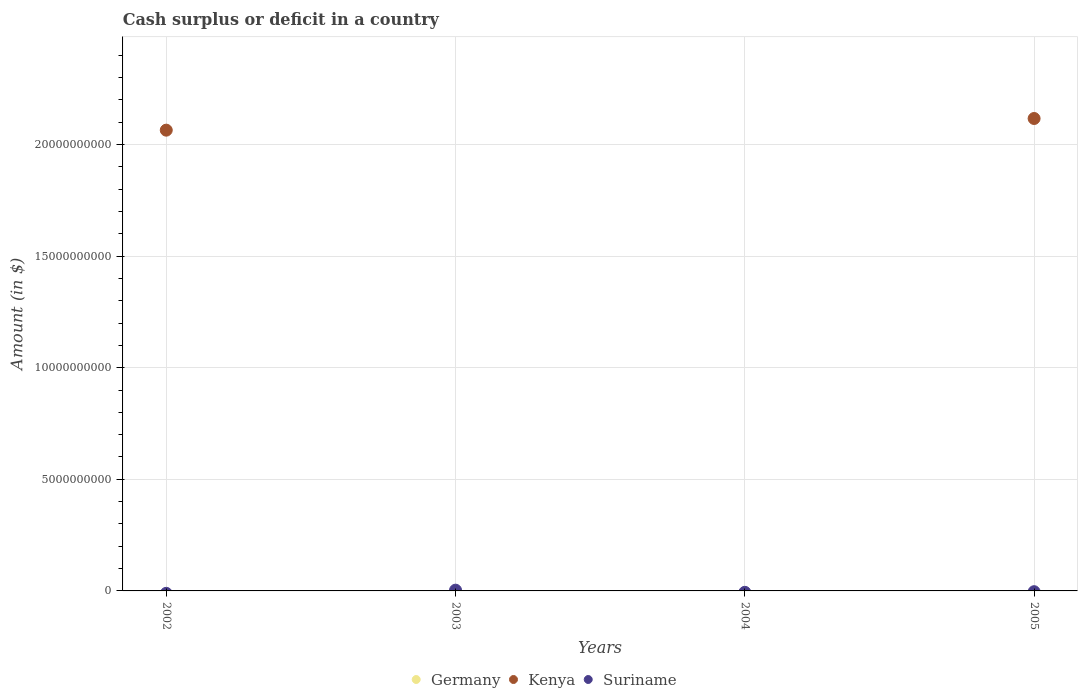What is the amount of cash surplus or deficit in Suriname in 2003?
Make the answer very short. 3.37e+07. Across all years, what is the maximum amount of cash surplus or deficit in Suriname?
Offer a very short reply. 3.37e+07. Across all years, what is the minimum amount of cash surplus or deficit in Kenya?
Provide a succinct answer. 0. What is the total amount of cash surplus or deficit in Suriname in the graph?
Offer a terse response. 3.37e+07. What is the difference between the amount of cash surplus or deficit in Kenya in 2002 and that in 2005?
Your answer should be compact. -5.22e+08. What is the difference between the amount of cash surplus or deficit in Germany in 2004 and the amount of cash surplus or deficit in Suriname in 2005?
Your response must be concise. 0. What is the average amount of cash surplus or deficit in Suriname per year?
Your answer should be compact. 8.43e+06. What is the difference between the highest and the lowest amount of cash surplus or deficit in Kenya?
Your answer should be compact. 2.12e+1. Does the amount of cash surplus or deficit in Germany monotonically increase over the years?
Provide a short and direct response. No. Is the amount of cash surplus or deficit in Kenya strictly greater than the amount of cash surplus or deficit in Germany over the years?
Offer a terse response. Yes. How many dotlines are there?
Provide a succinct answer. 2. What is the difference between two consecutive major ticks on the Y-axis?
Offer a terse response. 5.00e+09. Does the graph contain grids?
Your answer should be very brief. Yes. Where does the legend appear in the graph?
Provide a short and direct response. Bottom center. What is the title of the graph?
Provide a succinct answer. Cash surplus or deficit in a country. Does "Europe(developing only)" appear as one of the legend labels in the graph?
Your response must be concise. No. What is the label or title of the Y-axis?
Give a very brief answer. Amount (in $). What is the Amount (in $) in Germany in 2002?
Provide a succinct answer. 0. What is the Amount (in $) of Kenya in 2002?
Offer a terse response. 2.06e+1. What is the Amount (in $) of Kenya in 2003?
Ensure brevity in your answer.  0. What is the Amount (in $) of Suriname in 2003?
Provide a short and direct response. 3.37e+07. What is the Amount (in $) in Suriname in 2004?
Offer a terse response. 0. What is the Amount (in $) of Kenya in 2005?
Offer a very short reply. 2.12e+1. Across all years, what is the maximum Amount (in $) in Kenya?
Offer a terse response. 2.12e+1. Across all years, what is the maximum Amount (in $) in Suriname?
Offer a terse response. 3.37e+07. Across all years, what is the minimum Amount (in $) of Kenya?
Make the answer very short. 0. What is the total Amount (in $) in Germany in the graph?
Provide a succinct answer. 0. What is the total Amount (in $) of Kenya in the graph?
Your answer should be very brief. 4.18e+1. What is the total Amount (in $) of Suriname in the graph?
Provide a short and direct response. 3.37e+07. What is the difference between the Amount (in $) in Kenya in 2002 and that in 2005?
Ensure brevity in your answer.  -5.22e+08. What is the difference between the Amount (in $) in Kenya in 2002 and the Amount (in $) in Suriname in 2003?
Keep it short and to the point. 2.06e+1. What is the average Amount (in $) in Germany per year?
Offer a very short reply. 0. What is the average Amount (in $) in Kenya per year?
Keep it short and to the point. 1.05e+1. What is the average Amount (in $) of Suriname per year?
Give a very brief answer. 8.43e+06. What is the ratio of the Amount (in $) of Kenya in 2002 to that in 2005?
Your answer should be compact. 0.98. What is the difference between the highest and the lowest Amount (in $) of Kenya?
Keep it short and to the point. 2.12e+1. What is the difference between the highest and the lowest Amount (in $) in Suriname?
Your answer should be compact. 3.37e+07. 